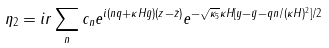Convert formula to latex. <formula><loc_0><loc_0><loc_500><loc_500>\eta _ { 2 } = i r \sum _ { n } c _ { n } e ^ { i ( n q + \kappa H \bar { y } ) ( z - \bar { z } ) } e ^ { - \sqrt { \kappa _ { 5 } } \kappa H [ y - \bar { y } - q n / ( \kappa H ) ^ { 2 } ] / 2 }</formula> 